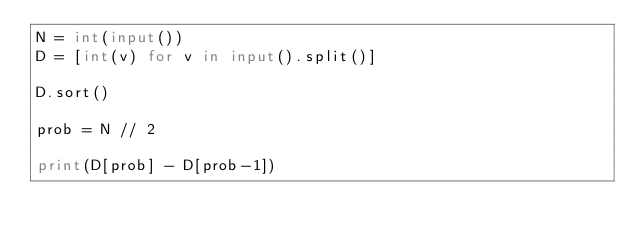Convert code to text. <code><loc_0><loc_0><loc_500><loc_500><_Python_>N = int(input())
D = [int(v) for v in input().split()]

D.sort()

prob = N // 2

print(D[prob] - D[prob-1])
</code> 